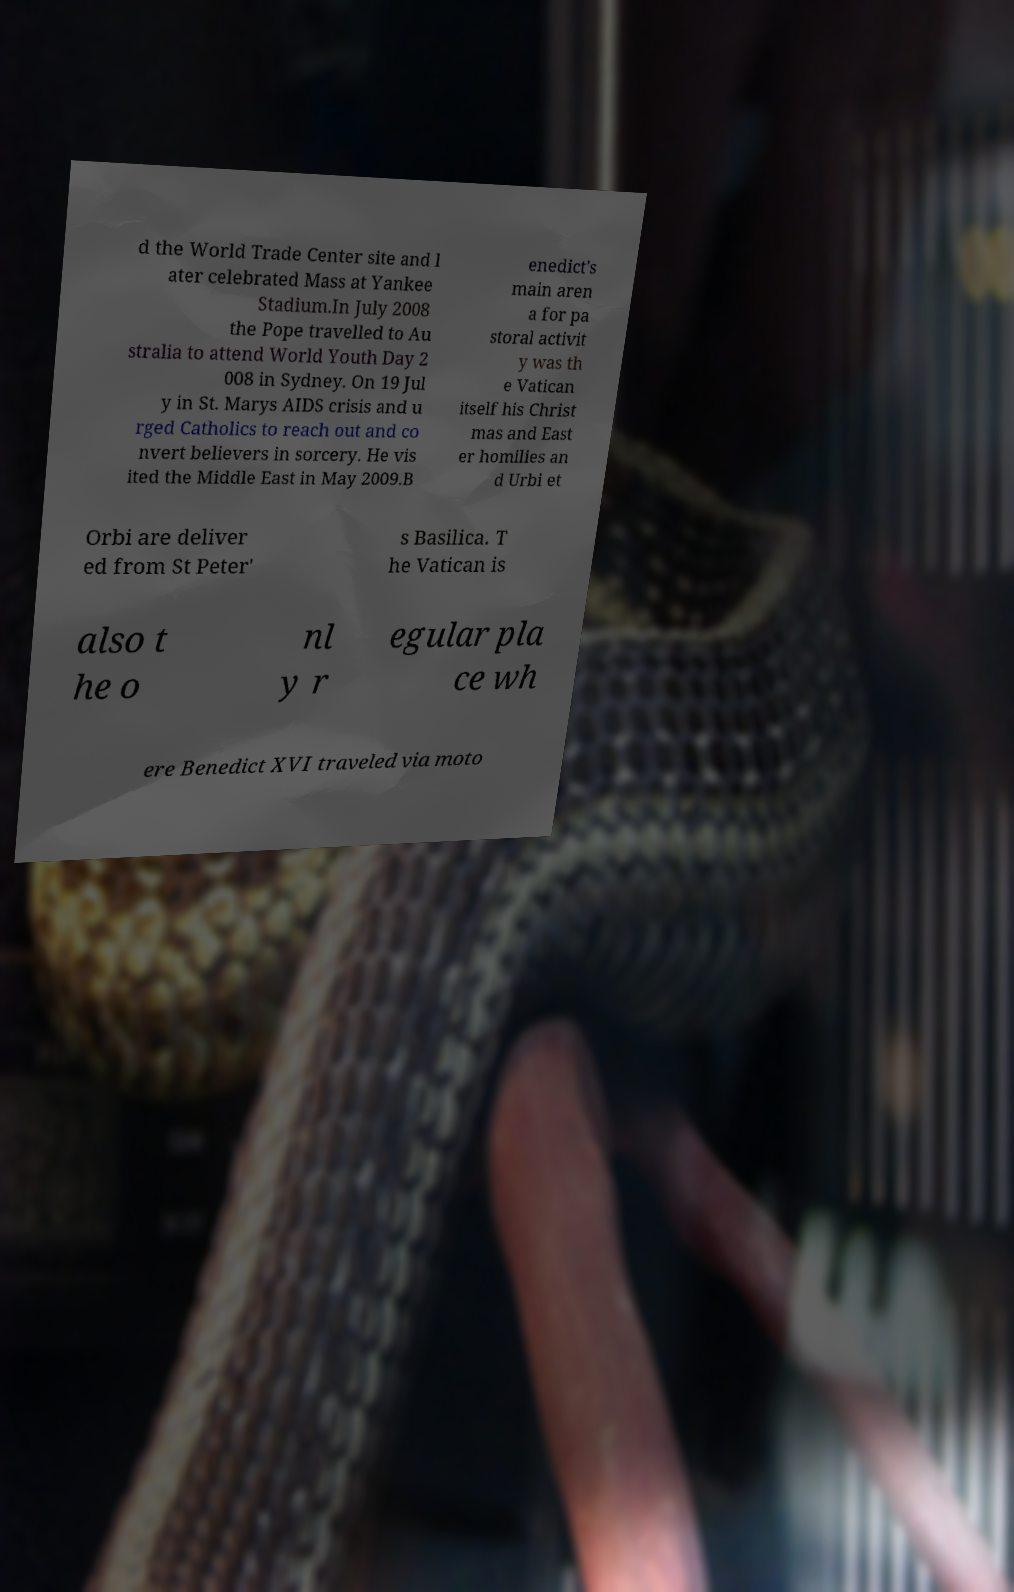Could you extract and type out the text from this image? d the World Trade Center site and l ater celebrated Mass at Yankee Stadium.In July 2008 the Pope travelled to Au stralia to attend World Youth Day 2 008 in Sydney. On 19 Jul y in St. Marys AIDS crisis and u rged Catholics to reach out and co nvert believers in sorcery. He vis ited the Middle East in May 2009.B enedict's main aren a for pa storal activit y was th e Vatican itself his Christ mas and East er homilies an d Urbi et Orbi are deliver ed from St Peter' s Basilica. T he Vatican is also t he o nl y r egular pla ce wh ere Benedict XVI traveled via moto 